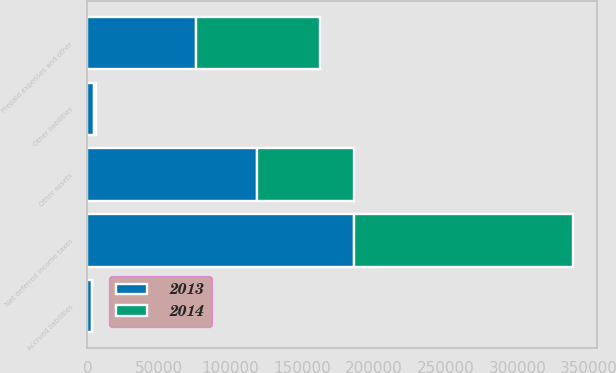Convert chart. <chart><loc_0><loc_0><loc_500><loc_500><stacked_bar_chart><ecel><fcel>Prepaid expenses and other<fcel>Other assets<fcel>Accrued liabilities<fcel>Other liabilities<fcel>Net deferred income taxes<nl><fcel>2013<fcel>75595<fcel>118280<fcel>3250<fcel>4650<fcel>185975<nl><fcel>2014<fcel>86634<fcel>67773<fcel>183<fcel>1545<fcel>152679<nl></chart> 